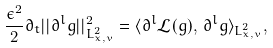<formula> <loc_0><loc_0><loc_500><loc_500>\frac { \epsilon ^ { 2 } } { 2 } \partial _ { t } | | \partial ^ { l } g | | _ { L ^ { 2 } _ { x , v } } ^ { 2 } = \langle \partial ^ { l } \mathcal { L } ( g ) , \, \partial ^ { l } g \rangle _ { L ^ { 2 } _ { x , v } } ,</formula> 